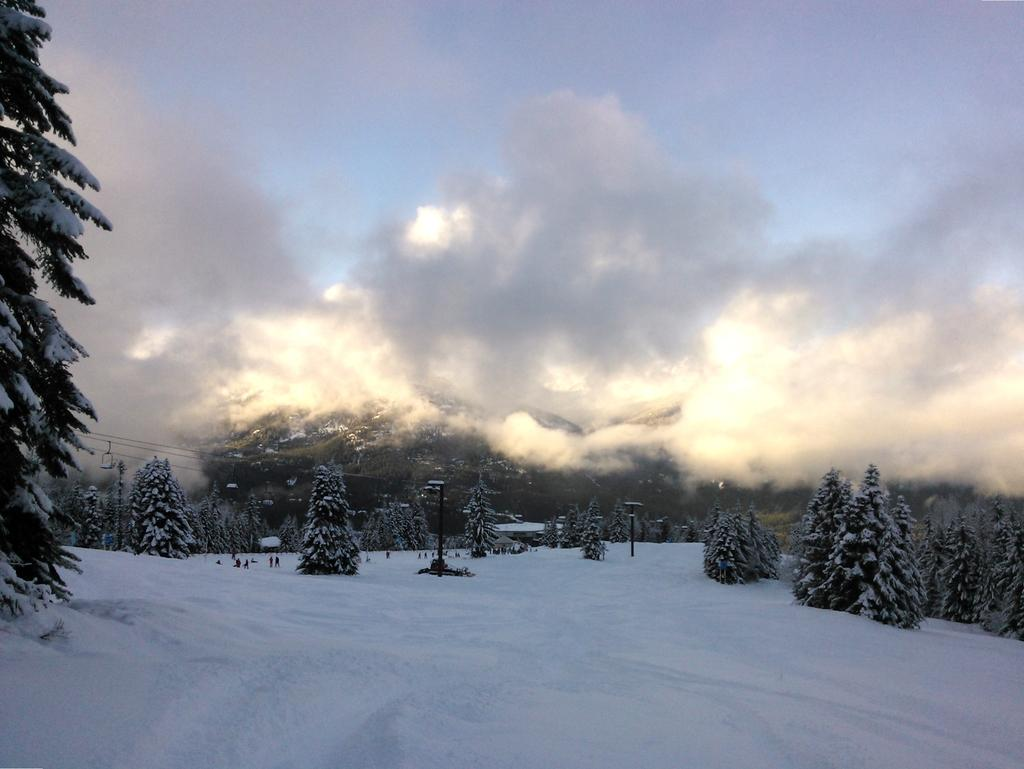What is the setting of the image? The image is an outside view. What type of weather is depicted in the image? There is snow at the bottom of the image, indicating a snowy environment. What can be seen in the background of the image? There are trees covered with snow in the background. What is visible at the top of the image? The sky is visible at the top of the image. What can be observed in the sky? Clouds are present in the sky. Can you see a snail crawling on the snow in the image? There is no snail present in the image; it only features snow, trees, and clouds. What type of ray is visible in the sky in the image? There is no ray visible in the sky in the image; only clouds are present. 